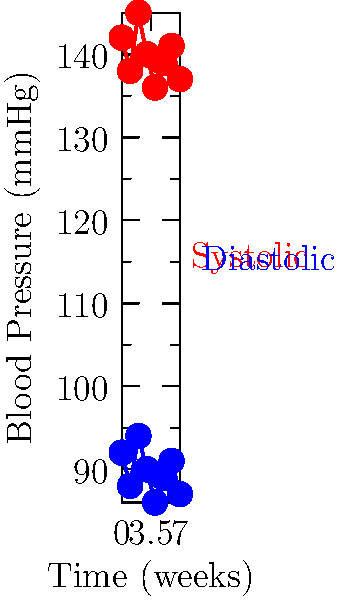Based on the blood pressure readings shown in the graph over an 8-week period, calculate the average pulse pressure and determine if there's a significant trend in the patient's blood pressure. How might these fluctuations impact the management of this senior patient's health? To answer this question, we need to follow these steps:

1. Calculate the pulse pressure for each measurement:
   Pulse pressure = Systolic pressure - Diastolic pressure
   Week 0: 142 - 92 = 50 mmHg
   Week 1: 138 - 88 = 50 mmHg
   Week 2: 145 - 94 = 51 mmHg
   Week 3: 140 - 90 = 50 mmHg
   Week 4: 136 - 86 = 50 mmHg
   Week 5: 139 - 89 = 50 mmHg
   Week 6: 141 - 91 = 50 mmHg
   Week 7: 137 - 87 = 50 mmHg

2. Calculate the average pulse pressure:
   Average pulse pressure = $\frac{50 + 50 + 51 + 50 + 50 + 50 + 50 + 50}{8} = 50.125$ mmHg

3. Analyze the trend:
   - Systolic pressure ranges from 136 to 145 mmHg
   - Diastolic pressure ranges from 86 to 94 mmHg
   - There is no clear upward or downward trend over the 8-week period

4. Impact on patient management:
   - The average blood pressure is consistently in the hypertensive range (>130/80 mmHg)
   - Fluctuations are relatively minor (within 9 mmHg for systolic and 8 mmHg for diastolic)
   - The consistent pulse pressure of about 50 mmHg suggests stable arterial compliance

5. Management considerations:
   - Regular monitoring is crucial due to the hypertensive readings
   - Lifestyle modifications may be recommended (diet, exercise, stress management)
   - Medication adjustments might be necessary if lifestyle changes are insufficient
   - The minor fluctuations suggest a need for continued observation rather than immediate intervention
Answer: Average pulse pressure: 50.125 mmHg. No significant trend. Management: regular monitoring, possible lifestyle modifications, and potential medication adjustments due to consistent hypertensive readings. 